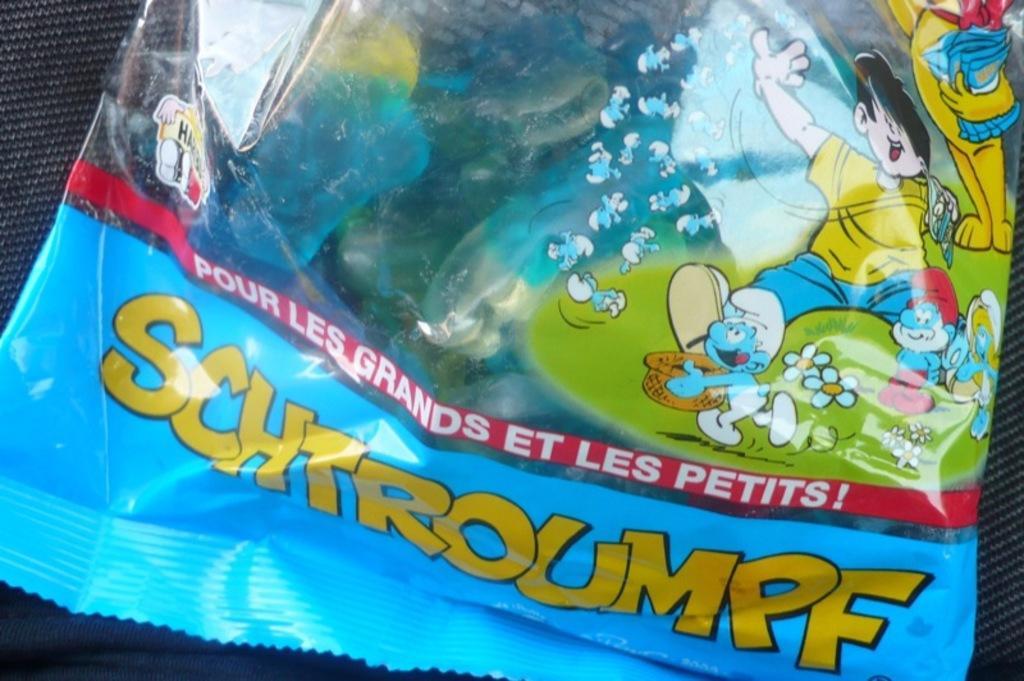Could you give a brief overview of what you see in this image? In this picture we can observe a blue color packet. We can observe yellow color word on the packet. On the right side there are cartoon pictures on this packet 